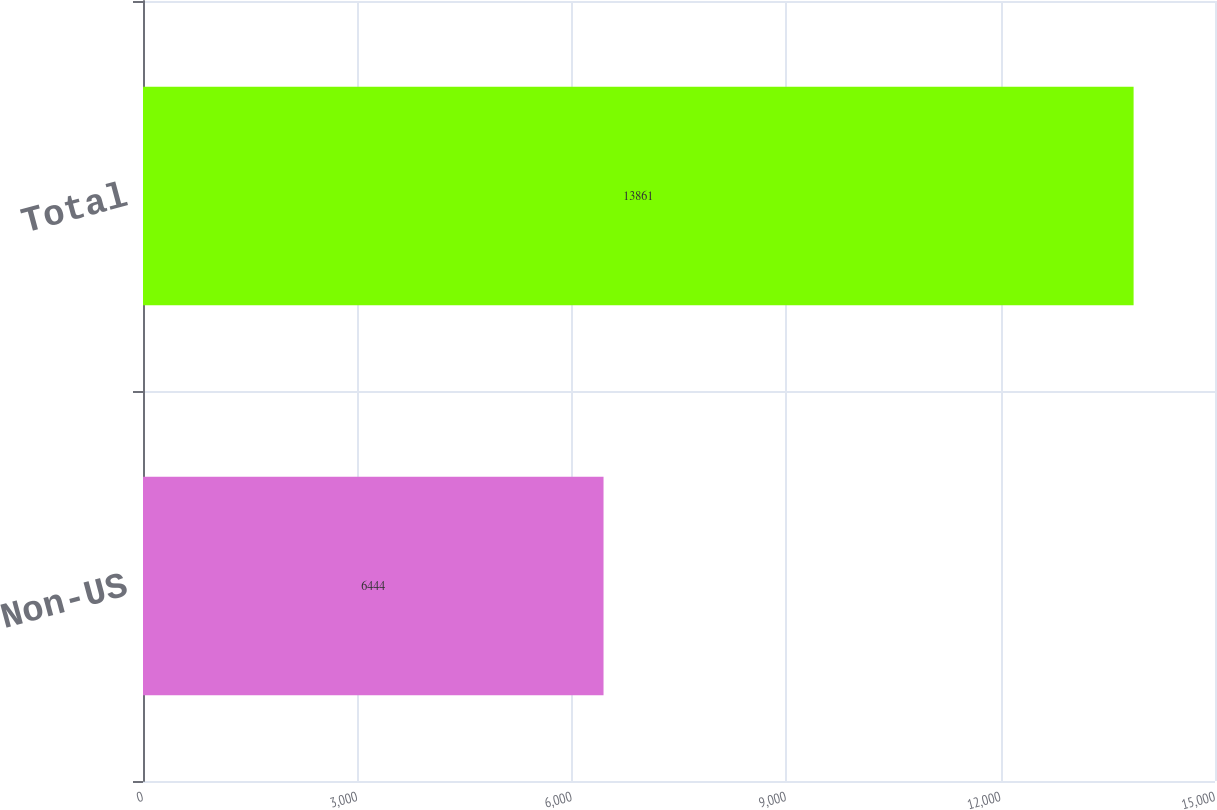Convert chart. <chart><loc_0><loc_0><loc_500><loc_500><bar_chart><fcel>Non-US<fcel>Total<nl><fcel>6444<fcel>13861<nl></chart> 